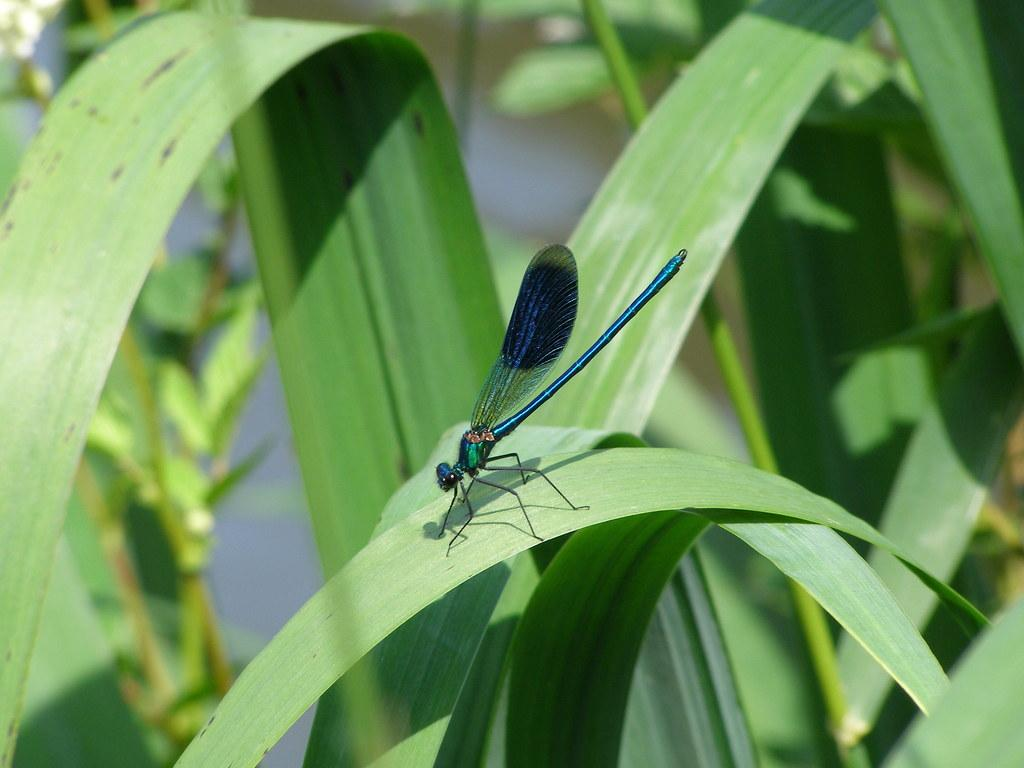What is the main subject of the image? The main subject of the image is the many plants. Are there any other living organisms present in the image? Yes, there is an insect in the image. Where is the insect located in relation to the plants? The insect is sitting on a leaf. What type of voice does the pig have in the image? There is no pig present in the image, so it is not possible to determine the type of voice it might have. 